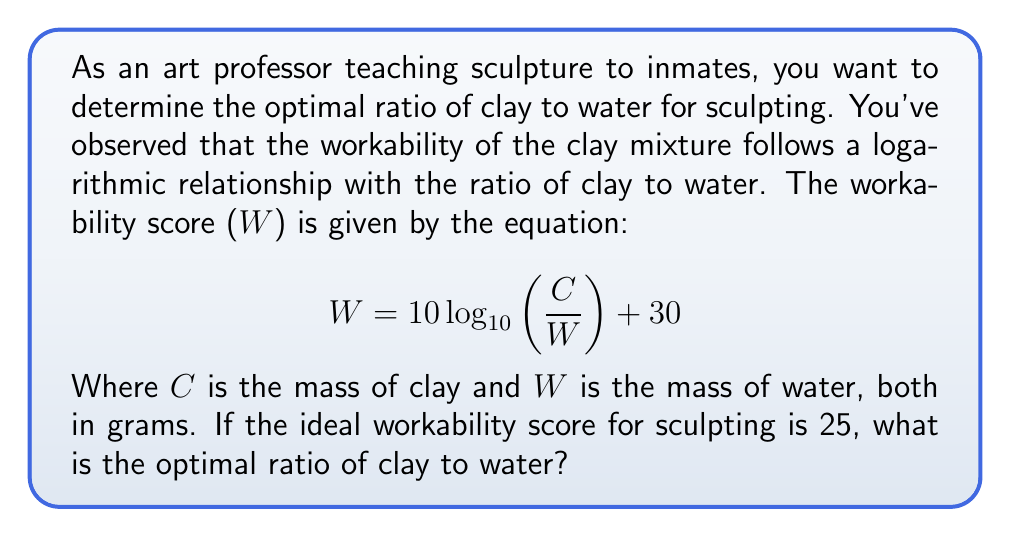Give your solution to this math problem. To solve this problem, we need to use the given logarithmic equation and work backwards to find the ratio of clay to water (C/W) that gives us the desired workability score.

1. Start with the given equation:
   $$ W = 10 \log_{10}\left(\frac{C}{W}\right) + 30 $$

2. Substitute the ideal workability score W = 25:
   $$ 25 = 10 \log_{10}\left(\frac{C}{W}\right) + 30 $$

3. Subtract 30 from both sides:
   $$ -5 = 10 \log_{10}\left(\frac{C}{W}\right) $$

4. Divide both sides by 10:
   $$ -0.5 = \log_{10}\left(\frac{C}{W}\right) $$

5. Apply the inverse function (10 to the power) to both sides:
   $$ 10^{-0.5} = \frac{C}{W} $$

6. Calculate the result:
   $$ \frac{C}{W} \approx 0.3162 $$

This means that the optimal ratio of clay to water is approximately 0.3162 to 1, or about 1 part clay to 3.16 parts water.
Answer: The optimal ratio of clay to water for sculpting is approximately 0.3162:1 or 1:3.16. 